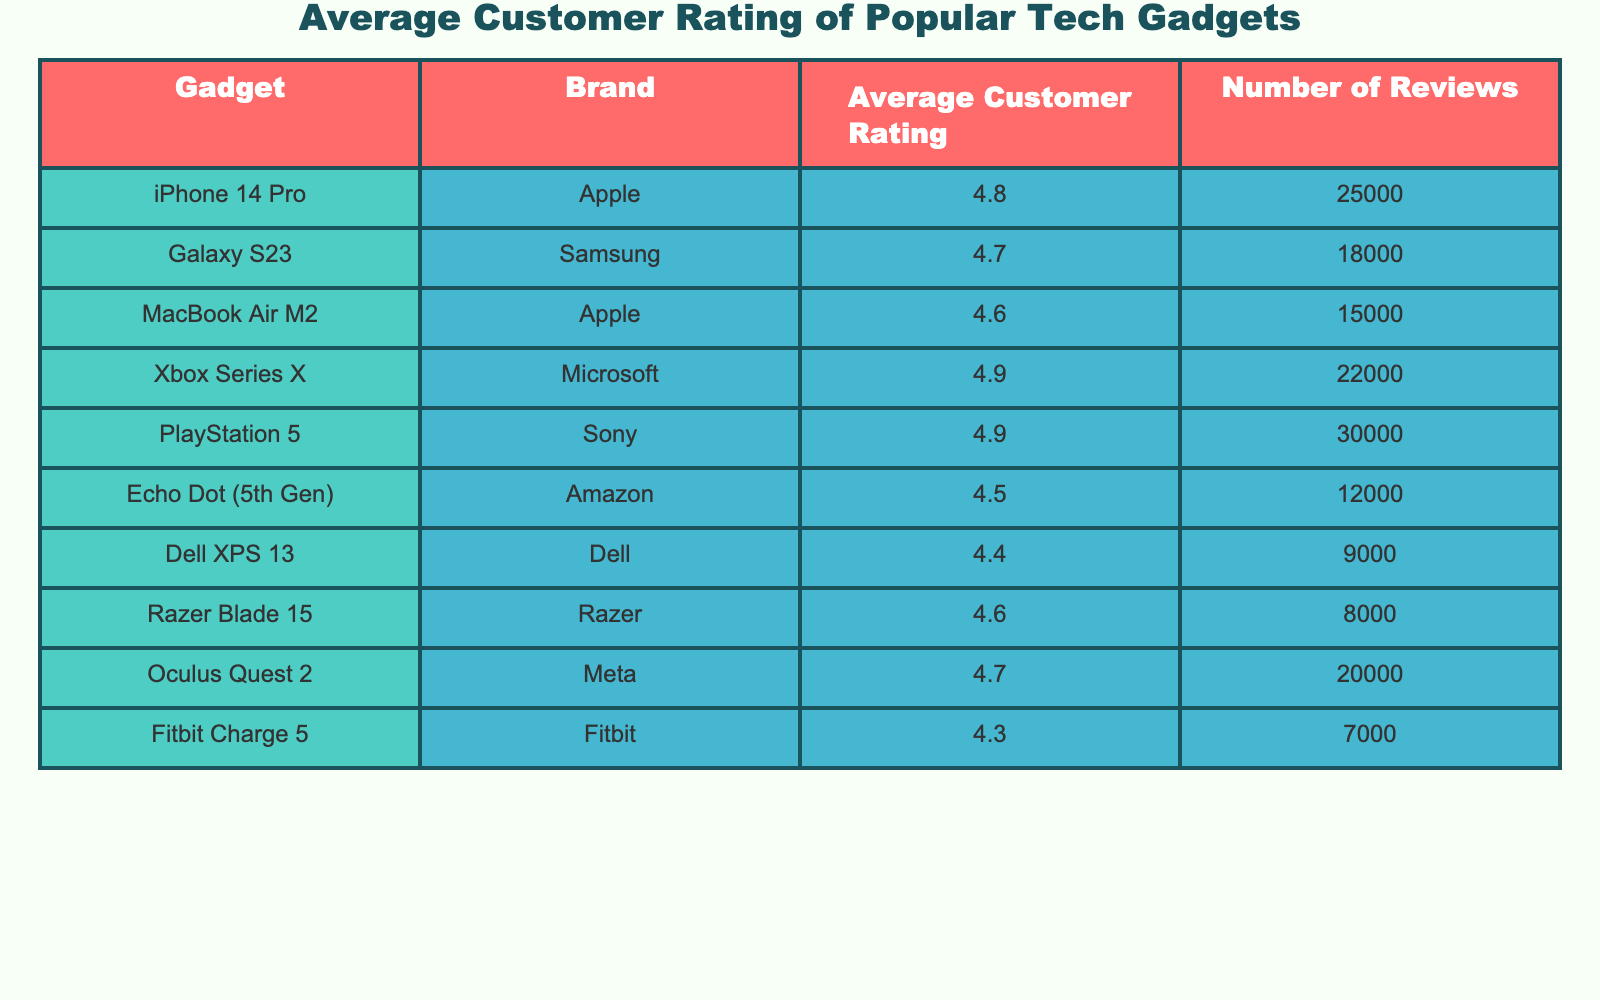What is the average customer rating for the Echo Dot (5th Gen)? The table lists the average customer rating for each gadget. For the Echo Dot (5th Gen), the table shows an average rating of 4.5.
Answer: 4.5 Which gadget has the highest average customer rating? The table provides average ratings for each gadget. Scanning through the ratings, the Xbox Series X and PlayStation 5 both share the highest rating at 4.9.
Answer: Xbox Series X, PlayStation 5 How many reviews does the MacBook Air M2 have? The table specifies the number of reviews for each gadget. For the MacBook Air M2, it indicates a total of 15,000 reviews.
Answer: 15000 What is the difference in average customer rating between the iPhone 14 Pro and the Dell XPS 13? To find the difference, subtract the average rating of the Dell XPS 13 (4.4) from that of the iPhone 14 Pro (4.8). This gives us 4.8 - 4.4 = 0.4.
Answer: 0.4 Is the average customer rating for the Fitbit Charge 5 higher than 4.5? The average rating for the Fitbit Charge 5 is listed as 4.3, which is less than 4.5. Therefore, the statement is false.
Answer: No Which brand has the most gadgets listed in the table? The table indicates gadgets from various brands. By counting, we find Apple has two devices (iPhone 14 Pro and MacBook Air M2), while other brands have either one device or two (Sony also has two with PlayStation 5 and Microsoft). Thus, both Apple and Sony share the most gadgets listed.
Answer: Apple, Sony What is the average rating for gadgets with more than 20,000 reviews? We take the gadgets with more than 20,000 reviews: iPhone 14 Pro (4.8), Xbox Series X (4.9), and PlayStation 5 (4.9). We calculate the average: (4.8 + 4.9 + 4.9) / 3 = 4.867, which rounds to 4.87.
Answer: 4.87 Are there any gadgets from Amazon listed in the table with a rating of 4.7 or higher? The only gadget from Amazon is the Echo Dot (5th Gen), which has an average rating of 4.5. Since 4.5 is less than 4.7, the answer is no.
Answer: No What is the total number of reviews for all gadgets combined? By summing the number of reviews for each gadget, we calculate: 25000 + 18000 + 15000 + 22000 + 30000 + 12000 + 9000 + 8000 + 20000 + 7000 =  192000.
Answer: 192000 